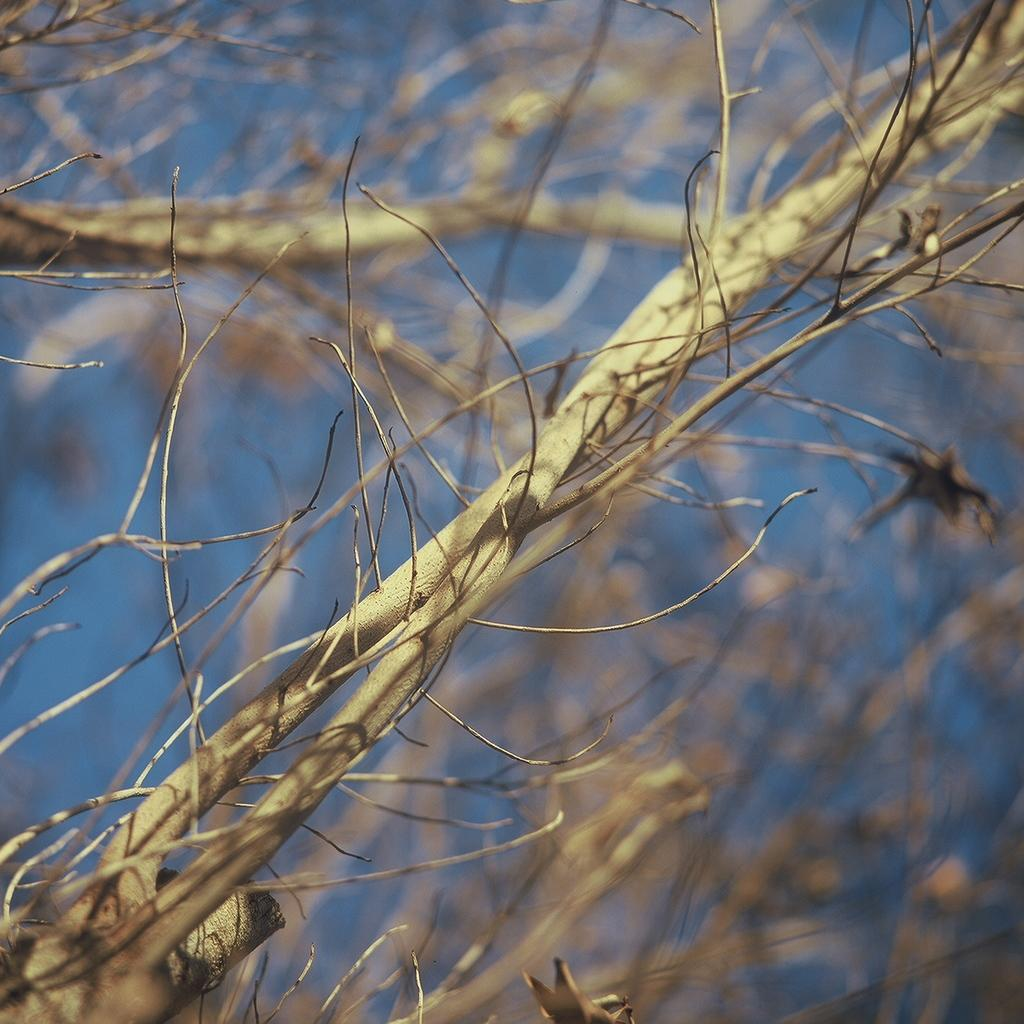What is the main subject of the image? The main subject of the image is a branch of a bare tree. Can you describe the background of the image? The background of the image is blurred. What can be seen in the background of the image? The sky is visible in the background of the image. What hobbies does the father in the image enjoy? There is no father present in the image, so it is not possible to answer that question. 